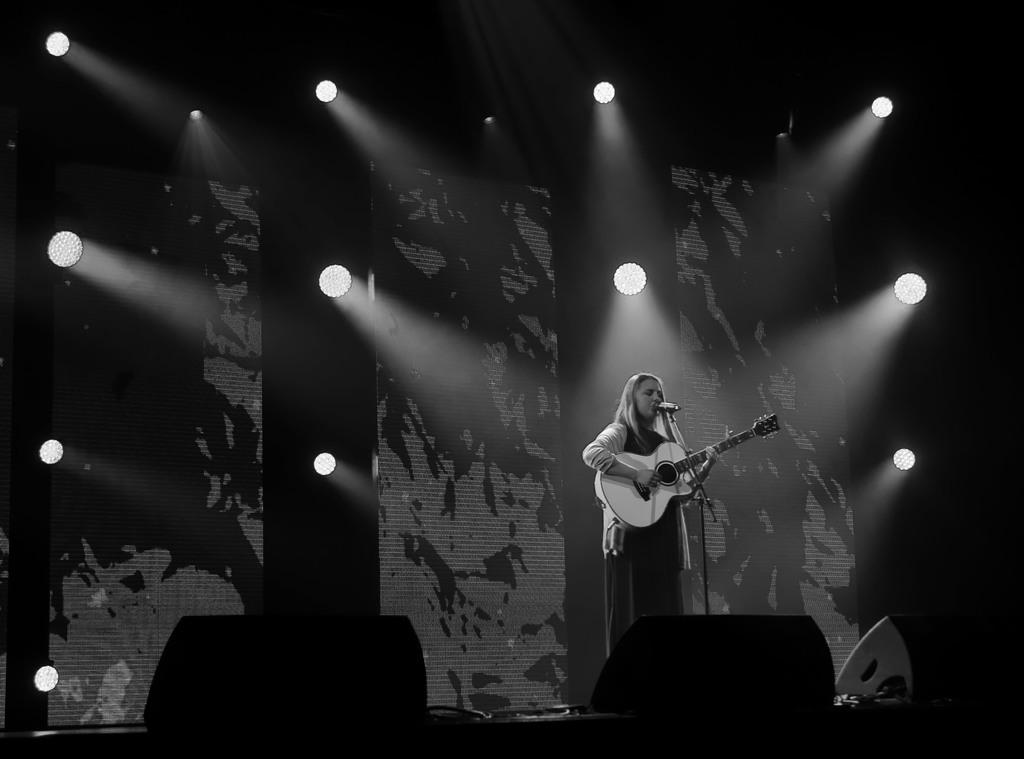Who is the main subject in the image? There is a woman in the image. What is the woman doing in the image? The woman is singing a song and playing a guitar. What object is the woman holding in the image? The woman is holding a microphone in the image. Where is the woman performing in the image? The woman is on a stage in the image. What type of whistle can be heard in the background of the image? There is no whistle present in the image; it only shows a woman singing and playing a guitar on a stage. 